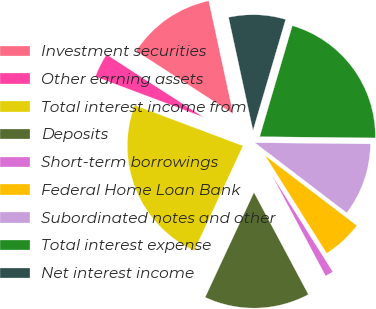<chart> <loc_0><loc_0><loc_500><loc_500><pie_chart><fcel>Investment securities<fcel>Other earning assets<fcel>Total interest income from<fcel>Deposits<fcel>Short-term borrowings<fcel>Federal Home Loan Bank<fcel>Subordinated notes and other<fcel>Total interest expense<fcel>Net interest income<nl><fcel>12.47%<fcel>3.42%<fcel>23.78%<fcel>14.73%<fcel>1.15%<fcel>5.68%<fcel>10.2%<fcel>20.62%<fcel>7.94%<nl></chart> 